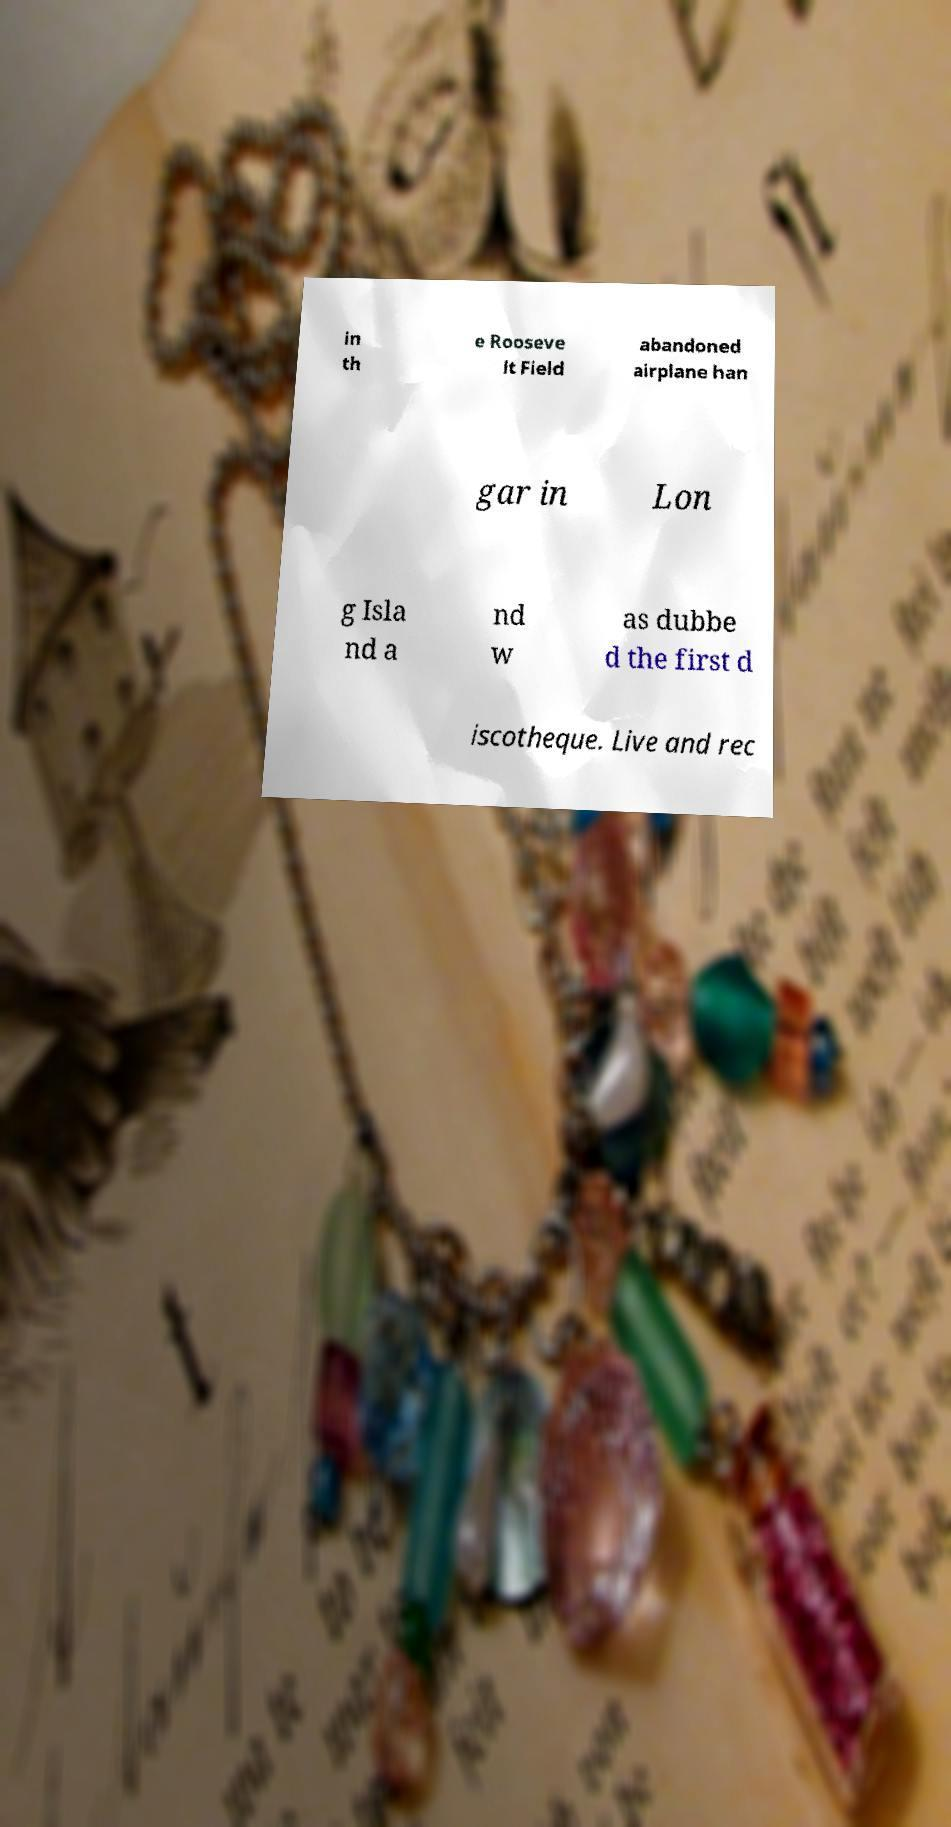I need the written content from this picture converted into text. Can you do that? in th e Rooseve lt Field abandoned airplane han gar in Lon g Isla nd a nd w as dubbe d the first d iscotheque. Live and rec 